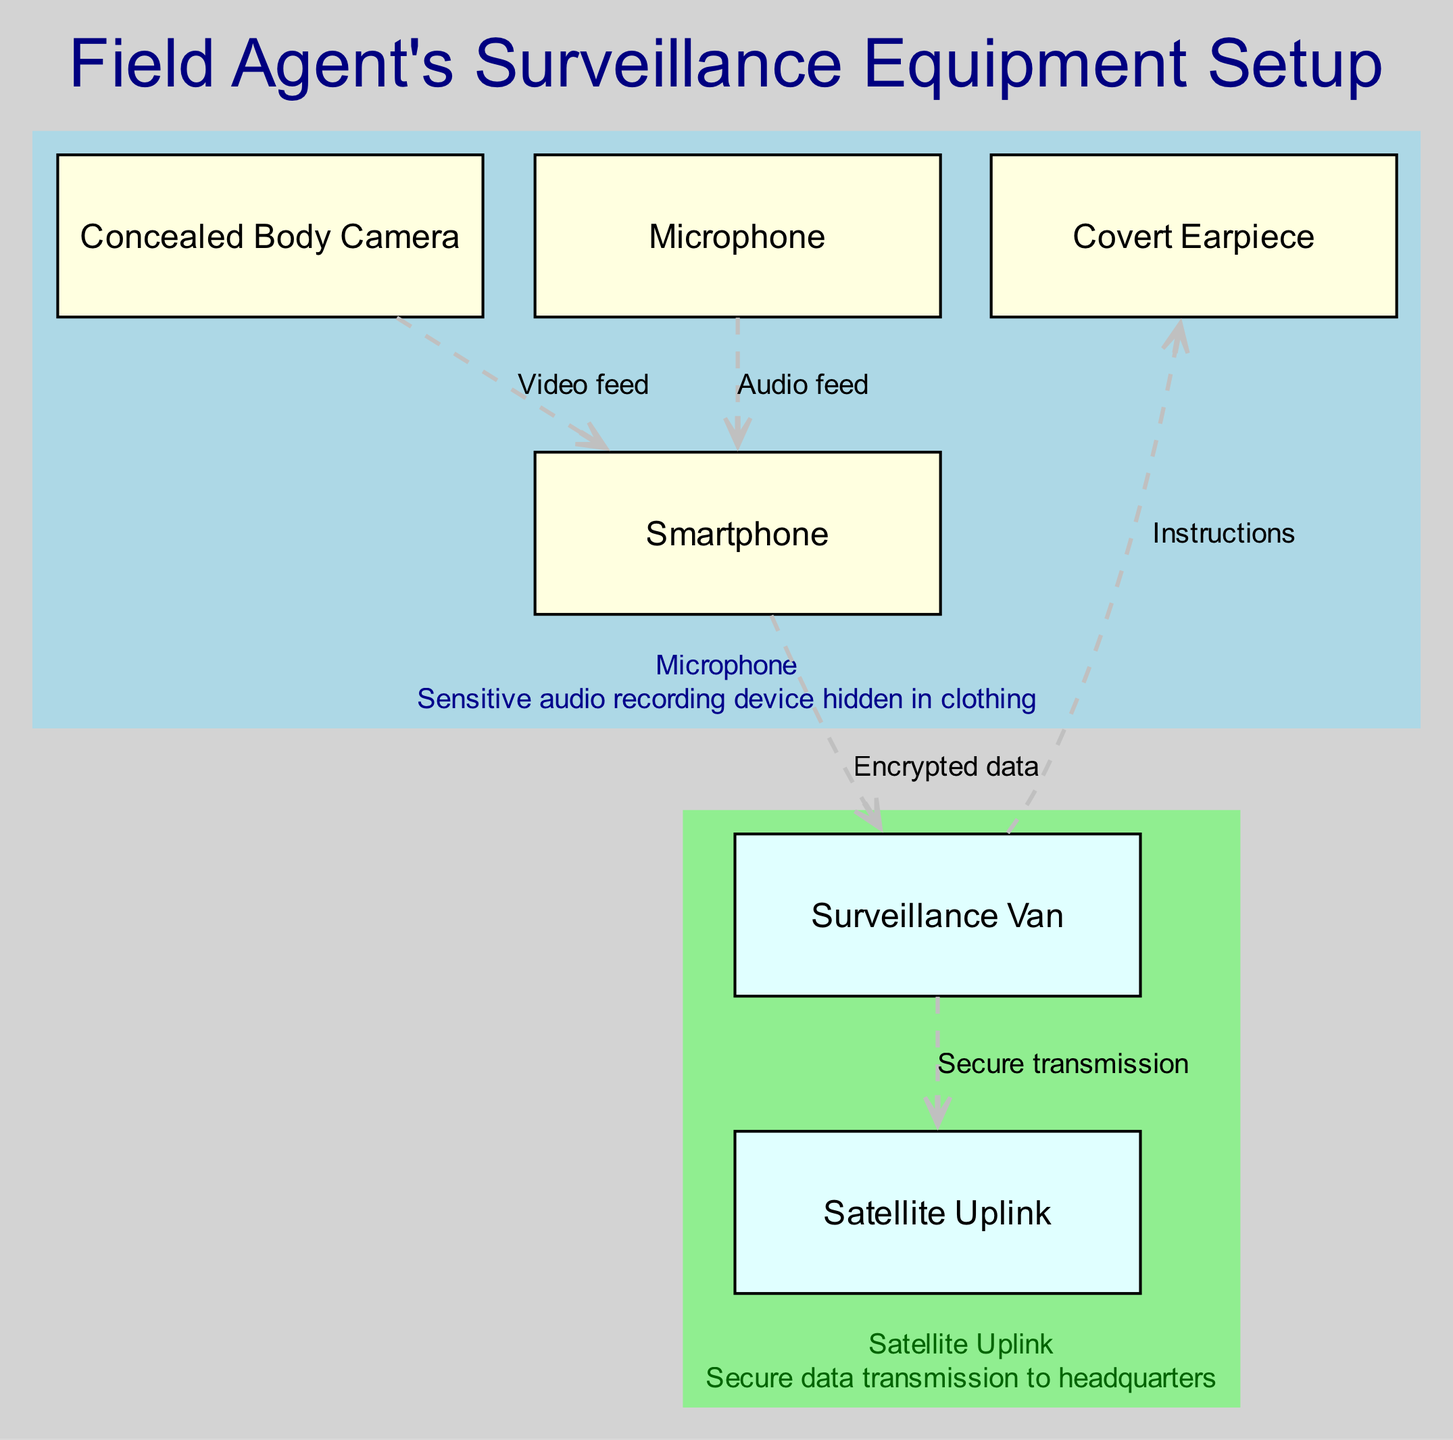What is the primary function of the concealed body camera? The concealed body camera is described as a high-resolution camera hidden in a button or tie clip, indicating its purpose is to capture video footage discreetly.
Answer: High-resolution camera hidden in a button or tie clip How many main components are there in the setup? The main components listed in the diagram include four items: concealed body camera, covert earpiece, smartphone, and microphone; thus, the total count is four.
Answer: 4 What type of connection exists between the microphone and the smartphone? The diagram indicates that the connection is labeled as "Audio feed," which clarifies that the microphone sends audio data to the smartphone.
Answer: Audio feed Which device sends encrypted data to the surveillance van? According to the diagram, the smartphone is responsible for sending encrypted data to the surveillance van, as specified in the connections section.
Answer: Smartphone What kind of instructions does the surveillance van provide to the covert earpiece? The diagram specifies that the surveillance van sends "Instructions" to the covert earpiece, indicating a communication relationship between these two components.
Answer: Instructions How does the surveillance van communicate with the satellite uplink? The connection from the surveillance van to the satellite uplink is labeled "Secure transmission," which indicates that the communication is secure by nature between these components.
Answer: Secure transmission What is the function of the surveillance van in this setup? The surveillance van is described as a mobile command center for monitoring and coordination, meaning it plays a critical role in overseeing operations during the surveillance.
Answer: Mobile command center for monitoring and coordination What are the types of devices connected to the smartphone? The smartphone is connected to the concealed body camera and the microphone, as indicated by the connections labeled "Video feed" and "Audio feed" respectively.
Answer: Concealed body camera, Microphone In what way is the smartphone described as being secure? The smartphone is characterized as an "encrypted device for data transmission and GPS tracking," highlighting its secure features and importance in the surveillance setup.
Answer: Encrypted device for data transmission and GPS tracking 